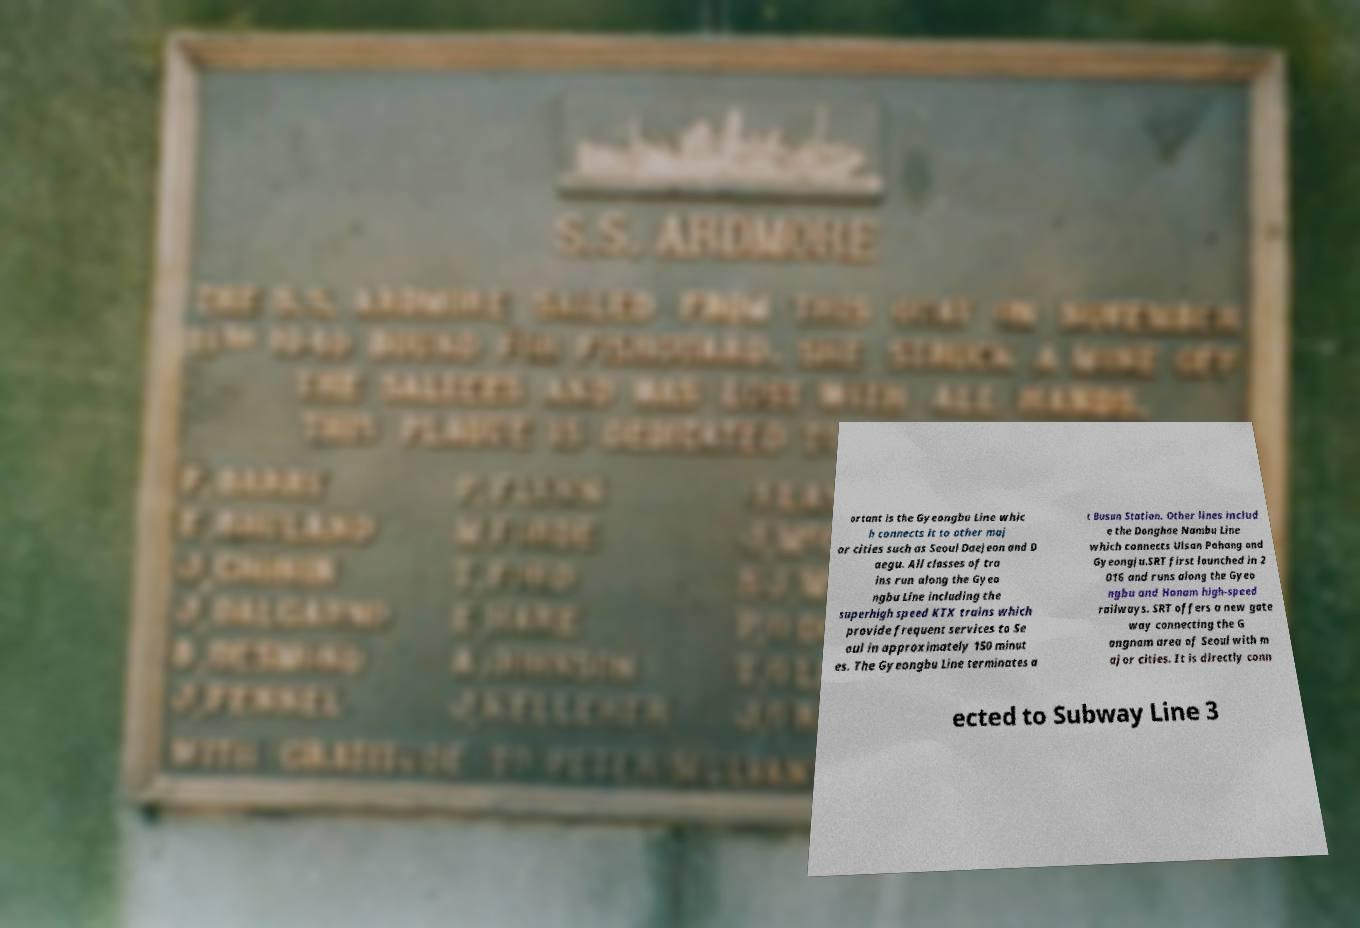Can you read and provide the text displayed in the image?This photo seems to have some interesting text. Can you extract and type it out for me? ortant is the Gyeongbu Line whic h connects it to other maj or cities such as Seoul Daejeon and D aegu. All classes of tra ins run along the Gyeo ngbu Line including the superhigh speed KTX trains which provide frequent services to Se oul in approximately 150 minut es. The Gyeongbu Line terminates a t Busan Station. Other lines includ e the Donghae Nambu Line which connects Ulsan Pohang and Gyeongju.SRT first launched in 2 016 and runs along the Gyeo ngbu and Honam high-speed railways. SRT offers a new gate way connecting the G angnam area of Seoul with m ajor cities. It is directly conn ected to Subway Line 3 